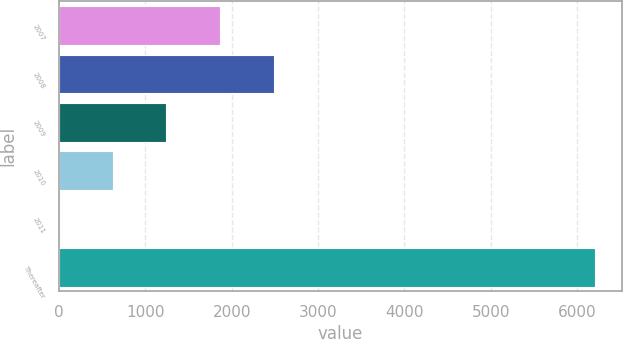Convert chart. <chart><loc_0><loc_0><loc_500><loc_500><bar_chart><fcel>2007<fcel>2008<fcel>2009<fcel>2010<fcel>2011<fcel>Thereafter<nl><fcel>1864.1<fcel>2484.8<fcel>1243.4<fcel>622.7<fcel>2<fcel>6209<nl></chart> 